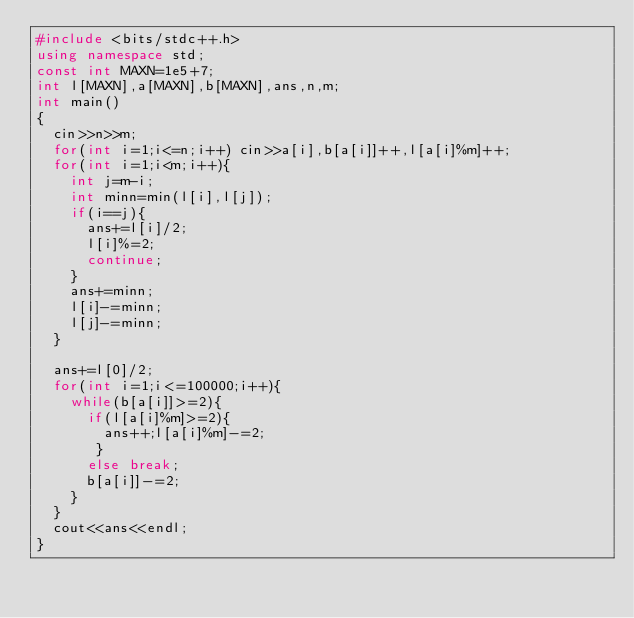Convert code to text. <code><loc_0><loc_0><loc_500><loc_500><_C++_>#include <bits/stdc++.h>
using namespace std;
const int MAXN=1e5+7;
int l[MAXN],a[MAXN],b[MAXN],ans,n,m;
int main()
{
	cin>>n>>m;
	for(int i=1;i<=n;i++) cin>>a[i],b[a[i]]++,l[a[i]%m]++;
	for(int i=1;i<m;i++){
		int j=m-i;
		int minn=min(l[i],l[j]);
		if(i==j){
			ans+=l[i]/2;
			l[i]%=2;
			continue;
		}
		ans+=minn;
		l[i]-=minn;
		l[j]-=minn;
	}
	
	ans+=l[0]/2;
	for(int i=1;i<=100000;i++){
		while(b[a[i]]>=2){
			if(l[a[i]%m]>=2){
			 	ans++;l[a[i]%m]-=2;
			 }
			else break;
			b[a[i]]-=2;
		}
	}
	cout<<ans<<endl;
}</code> 